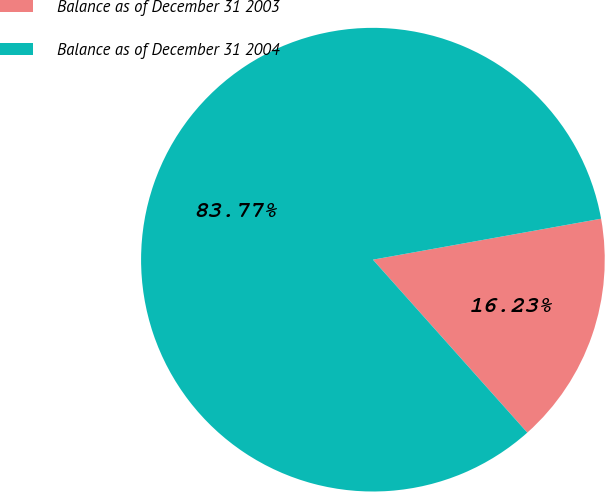Convert chart. <chart><loc_0><loc_0><loc_500><loc_500><pie_chart><fcel>Balance as of December 31 2003<fcel>Balance as of December 31 2004<nl><fcel>16.23%<fcel>83.77%<nl></chart> 